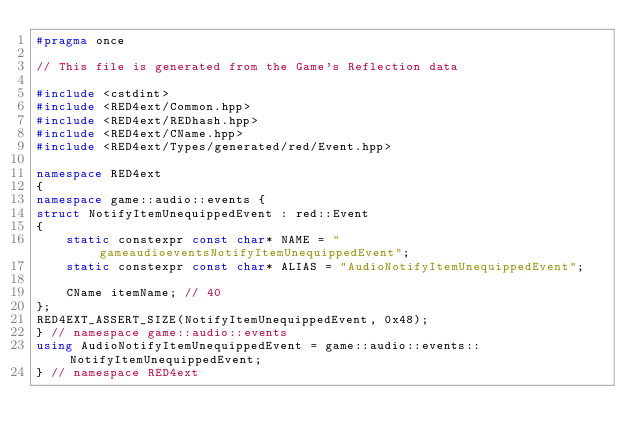Convert code to text. <code><loc_0><loc_0><loc_500><loc_500><_C++_>#pragma once

// This file is generated from the Game's Reflection data

#include <cstdint>
#include <RED4ext/Common.hpp>
#include <RED4ext/REDhash.hpp>
#include <RED4ext/CName.hpp>
#include <RED4ext/Types/generated/red/Event.hpp>

namespace RED4ext
{
namespace game::audio::events { 
struct NotifyItemUnequippedEvent : red::Event
{
    static constexpr const char* NAME = "gameaudioeventsNotifyItemUnequippedEvent";
    static constexpr const char* ALIAS = "AudioNotifyItemUnequippedEvent";

    CName itemName; // 40
};
RED4EXT_ASSERT_SIZE(NotifyItemUnequippedEvent, 0x48);
} // namespace game::audio::events
using AudioNotifyItemUnequippedEvent = game::audio::events::NotifyItemUnequippedEvent;
} // namespace RED4ext
</code> 